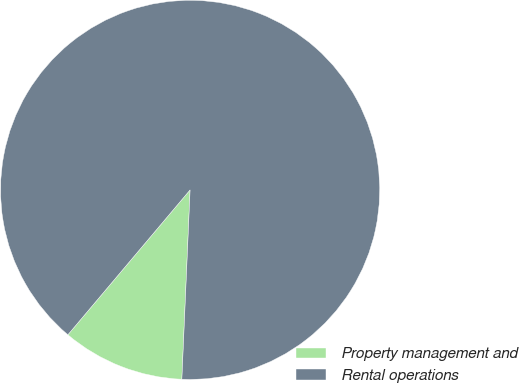<chart> <loc_0><loc_0><loc_500><loc_500><pie_chart><fcel>Property management and<fcel>Rental operations<nl><fcel>10.46%<fcel>89.54%<nl></chart> 